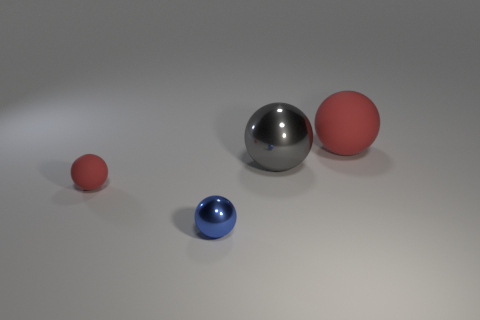Is the tiny sphere behind the blue object made of the same material as the gray ball?
Offer a terse response. No. Is the red thing right of the small matte object made of the same material as the red ball left of the large rubber ball?
Keep it short and to the point. Yes. Is the number of red things behind the small rubber ball greater than the number of cyan objects?
Make the answer very short. Yes. What color is the rubber sphere to the left of the red thing that is to the right of the gray object?
Offer a very short reply. Red. The red matte object that is the same size as the gray object is what shape?
Offer a terse response. Sphere. Are there an equal number of tiny rubber objects in front of the tiny red rubber sphere and big gray spheres?
Offer a very short reply. No. There is a red ball that is behind the red matte thing in front of the red object right of the large shiny sphere; what is it made of?
Your answer should be very brief. Rubber. There is a big gray thing that is made of the same material as the small blue thing; what shape is it?
Make the answer very short. Sphere. Is there anything else that is the same color as the big metal ball?
Offer a very short reply. No. There is a small sphere that is to the right of the small object that is to the left of the small blue metal thing; how many large objects are in front of it?
Give a very brief answer. 0. 